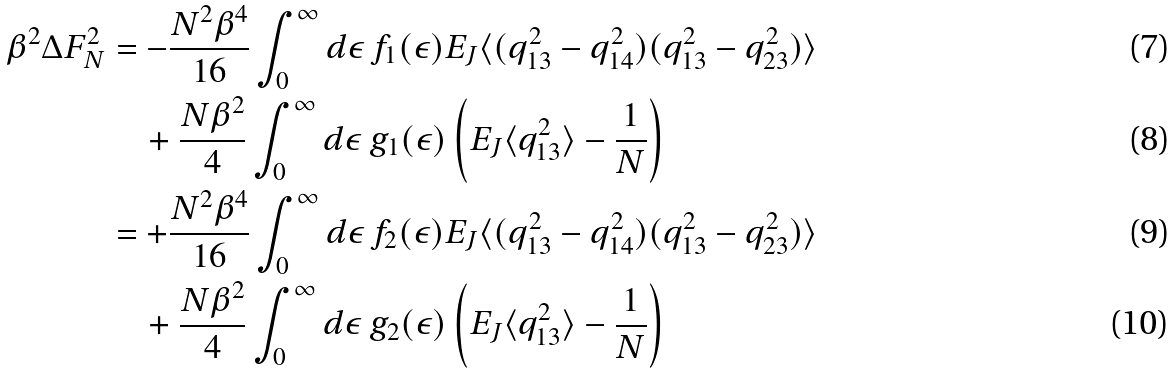<formula> <loc_0><loc_0><loc_500><loc_500>\beta ^ { 2 } \Delta F _ { N } ^ { 2 } & = - \frac { N ^ { 2 } \beta ^ { 4 } } { 1 6 } \int _ { 0 } ^ { \infty } d \epsilon \, f _ { 1 } ( \epsilon ) E _ { J } \langle ( q _ { 1 3 } ^ { 2 } - q _ { 1 4 } ^ { 2 } ) ( q _ { 1 3 } ^ { 2 } - q _ { 2 3 } ^ { 2 } ) \rangle \\ & \quad + \frac { N \beta ^ { 2 } } { 4 } \int _ { 0 } ^ { \infty } d \epsilon \, g _ { 1 } ( \epsilon ) \left ( E _ { J } \langle q _ { 1 3 } ^ { 2 } \rangle - \frac { 1 } { N } \right ) \\ & = + \frac { N ^ { 2 } \beta ^ { 4 } } { 1 6 } \int _ { 0 } ^ { \infty } d \epsilon \, f _ { 2 } ( \epsilon ) E _ { J } \langle ( q _ { 1 3 } ^ { 2 } - q _ { 1 4 } ^ { 2 } ) ( q _ { 1 3 } ^ { 2 } - q _ { 2 3 } ^ { 2 } ) \rangle \\ & \quad + \frac { N \beta ^ { 2 } } { 4 } \int _ { 0 } ^ { \infty } d \epsilon \, g _ { 2 } ( \epsilon ) \left ( E _ { J } \langle q _ { 1 3 } ^ { 2 } \rangle - \frac { 1 } { N } \right )</formula> 